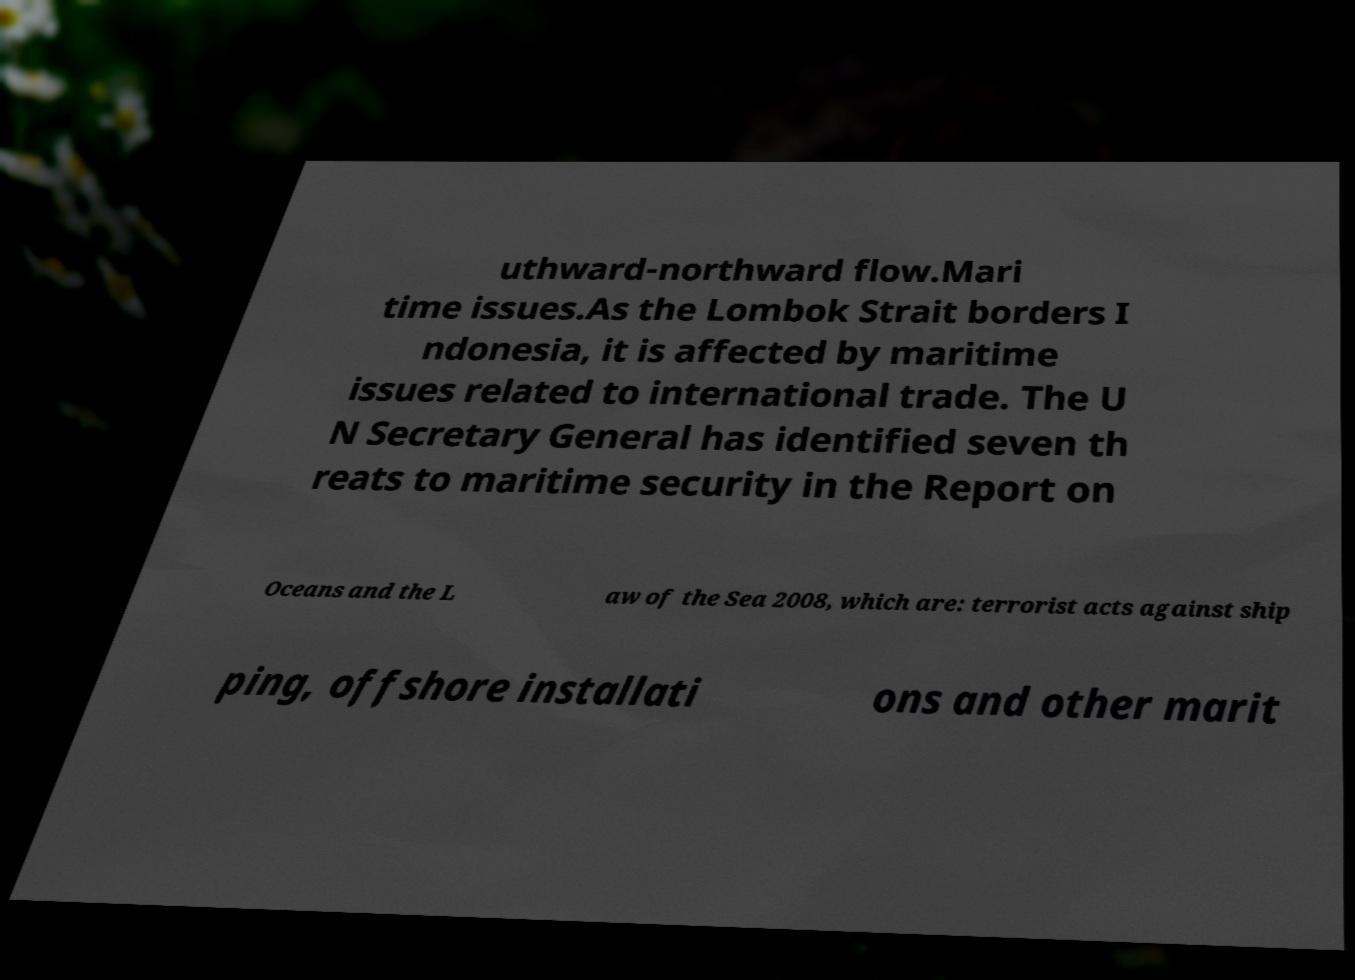For documentation purposes, I need the text within this image transcribed. Could you provide that? uthward-northward flow.Mari time issues.As the Lombok Strait borders I ndonesia, it is affected by maritime issues related to international trade. The U N Secretary General has identified seven th reats to maritime security in the Report on Oceans and the L aw of the Sea 2008, which are: terrorist acts against ship ping, offshore installati ons and other marit 